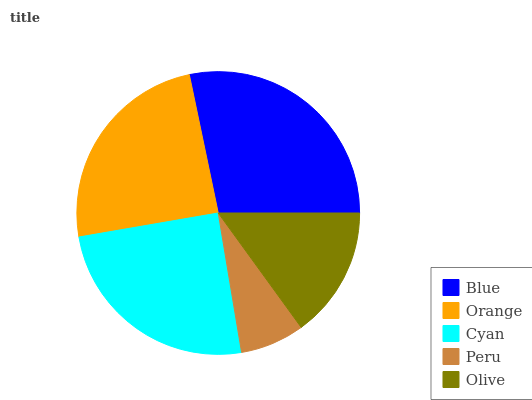Is Peru the minimum?
Answer yes or no. Yes. Is Blue the maximum?
Answer yes or no. Yes. Is Orange the minimum?
Answer yes or no. No. Is Orange the maximum?
Answer yes or no. No. Is Blue greater than Orange?
Answer yes or no. Yes. Is Orange less than Blue?
Answer yes or no. Yes. Is Orange greater than Blue?
Answer yes or no. No. Is Blue less than Orange?
Answer yes or no. No. Is Orange the high median?
Answer yes or no. Yes. Is Orange the low median?
Answer yes or no. Yes. Is Olive the high median?
Answer yes or no. No. Is Blue the low median?
Answer yes or no. No. 